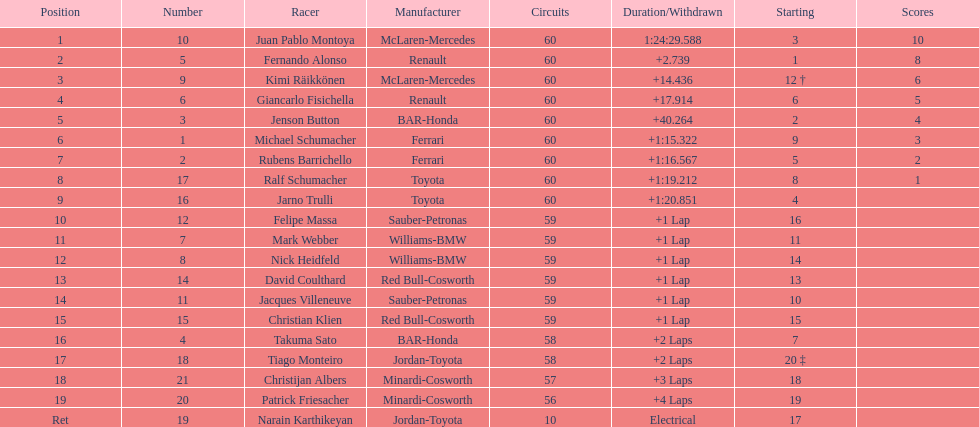After 8th position, how many points does a driver receive? 0. 